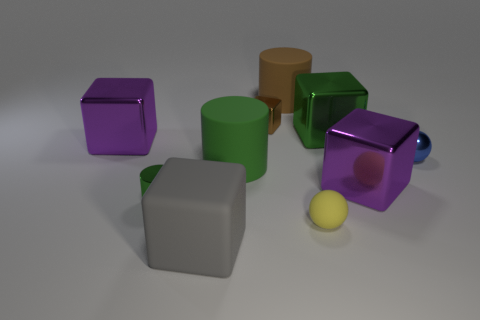What number of tiny spheres are there?
Offer a terse response. 2. Are there any large green metallic things to the left of the yellow object?
Your answer should be very brief. No. Do the purple object that is to the right of the yellow rubber sphere and the green thing on the left side of the large gray matte object have the same material?
Make the answer very short. Yes. Is the number of small metal blocks that are on the left side of the small green thing less than the number of red metallic cubes?
Your answer should be very brief. No. There is a tiny object that is behind the shiny sphere; what is its color?
Provide a short and direct response. Brown. The brown thing to the right of the brown shiny object on the right side of the big gray matte object is made of what material?
Make the answer very short. Rubber. Are there any purple metallic balls that have the same size as the gray cube?
Provide a succinct answer. No. What number of things are either objects that are right of the brown cylinder or metallic cubes in front of the blue metal ball?
Offer a terse response. 4. Is the size of the ball in front of the blue metal ball the same as the purple shiny cube left of the small rubber thing?
Provide a succinct answer. No. Is there a yellow object behind the small shiny object that is to the right of the brown cube?
Keep it short and to the point. No. 